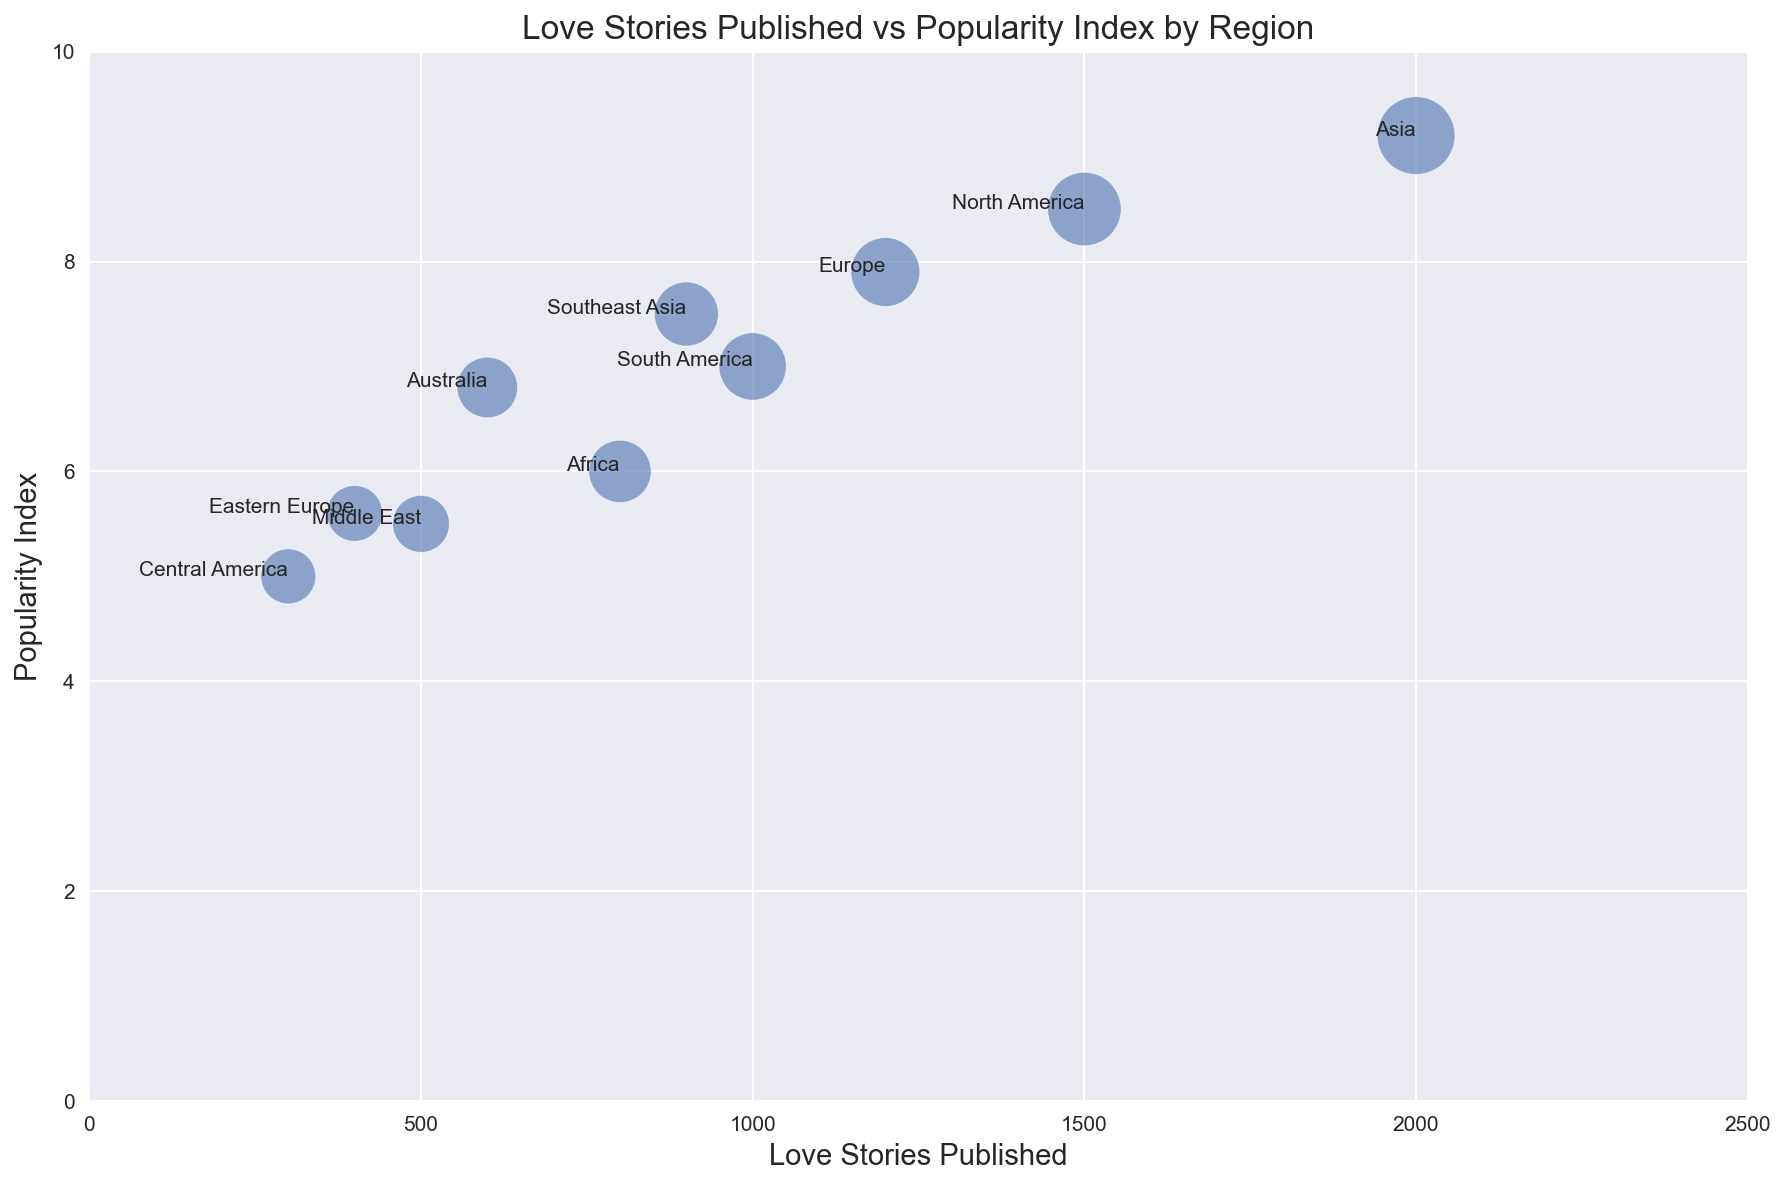Which region has the highest number of love stories published? Looking at the x-axis, Asia has the highest number of love stories published at 2000.
Answer: Asia Which region has the lowest popularity index for love stories? From the y-axis, Central America has the lowest popularity index at 5.0.
Answer: Central America How much higher is the popularity index of love stories in Asia compared to Africa? Asia has a popularity index of 9.2 and Africa has 6.0. The difference is 9.2 - 6.0 = 3.2.
Answer: 3.2 What is the total number of love stories published in Europe and North America combined? Europe has 1200 and North America has 1500. The total is 1200 + 1500 = 2700.
Answer: 2700 Which regions have a popularity index greater than 8.0? Looking at the y-axis, North America (8.5) and Asia (9.2) have popularity indexes greater than 8.0.
Answer: North America, Asia What is the average popularity index across Africa, Australia, and Southeast Asia? Africa's index is 6.0, Australia’s is 6.8, and Southeast Asia’s is 7.5. Average is (6.0 + 6.8 + 7.5) / 3 = 6.77.
Answer: 6.77 Which region has a larger bubble size, South America or Southeast Asia? Looking at the sizes of the bubbles, Southeast Asia's bubble is larger at 95 compared to South America's 105.
Answer: South America Compare the number of love stories published in Eastern Europe and the Middle East. Which region has more? Eastern Europe has 400 and the Middle East has 500. The Middle East has more published love stories.
Answer: Middle East What is the relationship between the number of love stories published and the bubble size in North America? For North America, there are 1500 stories published and a bubble size of 125. This reflects a larger bubble size corresponding to a higher number of published stories.
Answer: Larger bubble, more stories published What region has closer numbers of published love stories compared to Africa and what is the difference? South America has 1000 published compared to Africa's 800. The difference is 1000 - 800 = 200.
Answer: South America, 200 